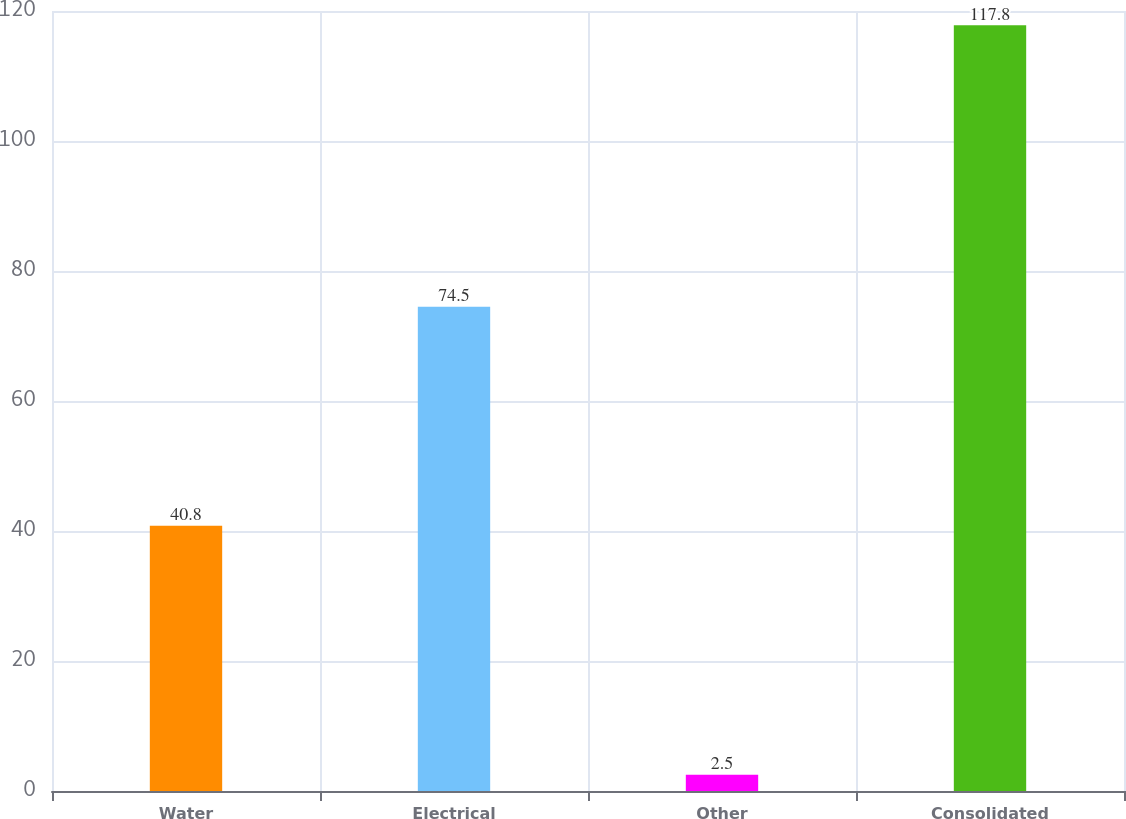<chart> <loc_0><loc_0><loc_500><loc_500><bar_chart><fcel>Water<fcel>Electrical<fcel>Other<fcel>Consolidated<nl><fcel>40.8<fcel>74.5<fcel>2.5<fcel>117.8<nl></chart> 